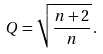<formula> <loc_0><loc_0><loc_500><loc_500>Q = \sqrt { \frac { n + 2 } { n } } \, .</formula> 